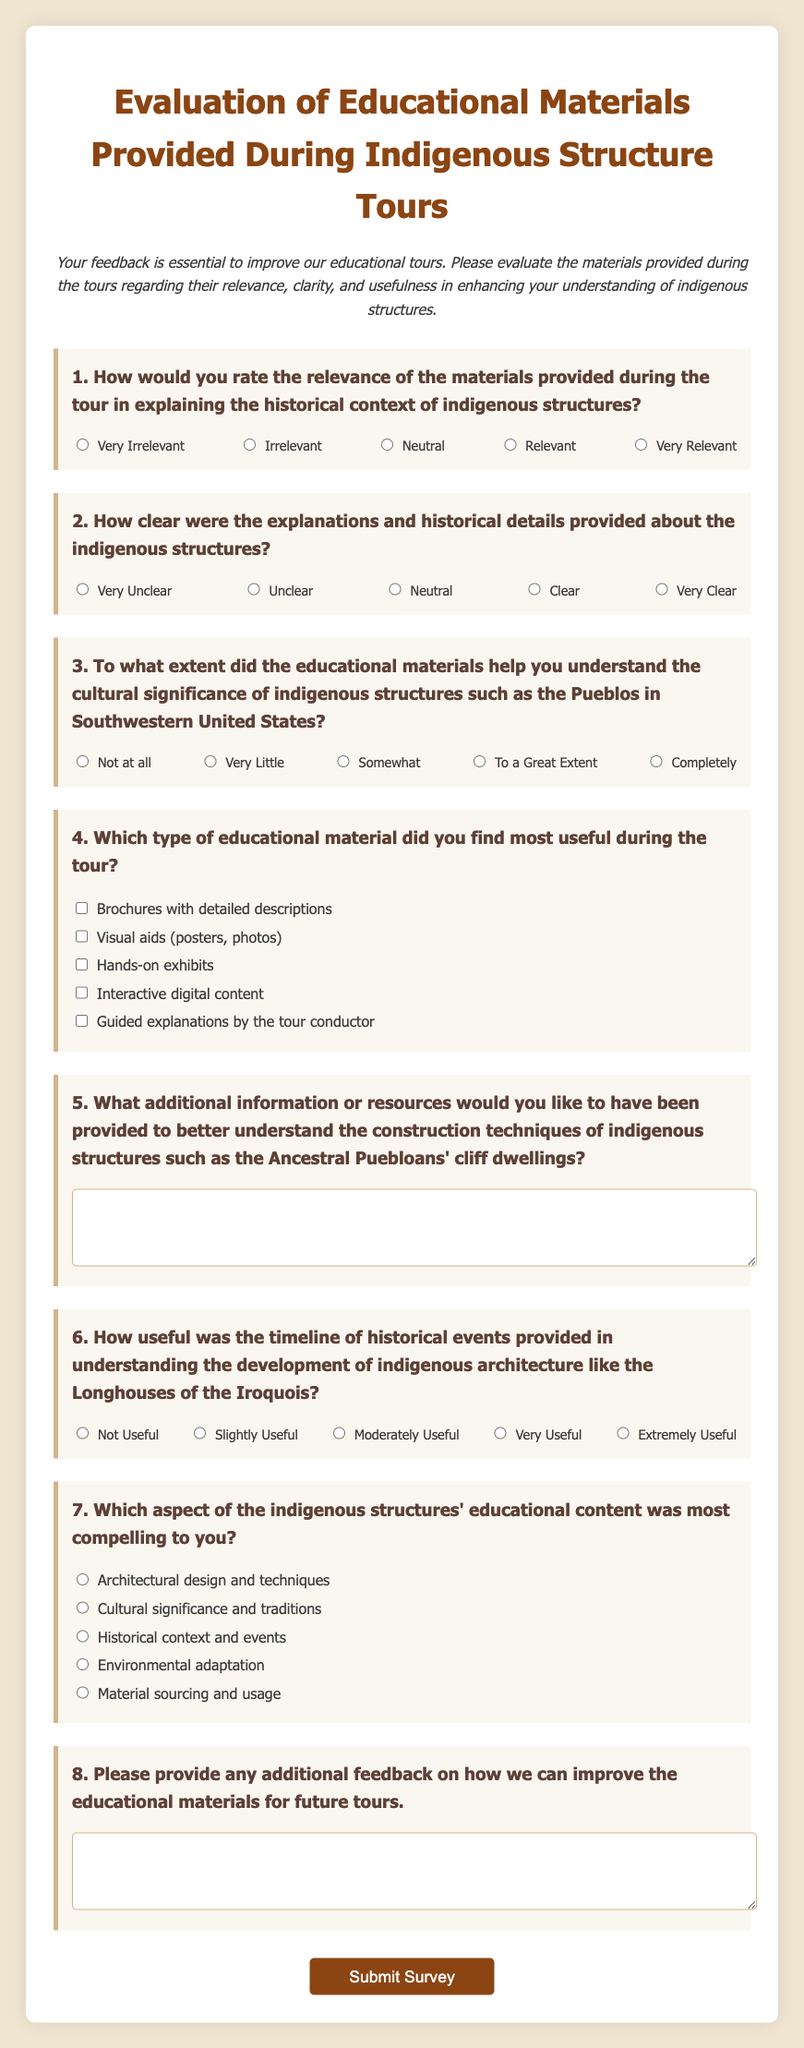What is the title of the survey? The title of the survey is mentioned at the top of the document as "Evaluation of Educational Materials Provided During Indigenous Structure Tours."
Answer: Evaluation of Educational Materials Provided During Indigenous Structure Tours What is the color of the background in the body of the document? The background color in the body of the document is specified in the CSS as "#f0e6d2."
Answer: #f0e6d2 How many main questions are included in the survey? The survey lists a total of eight main questions to be answered by the participants.
Answer: 8 What is the minimum rating on the Likert scale for question 1? The minimum rating on the Likert scale for question 1 is clearly defined as "Very Irrelevant."
Answer: Very Irrelevant Which type of educational material is listed last in question 4? The last type of educational material listed in question 4 is "Guided explanations by the tour conductor."
Answer: Guided explanations by the tour conductor Which aspect of the indigenous structures is question 7 asking about? Question 7 is specifically asking about the "aspect of the indigenous structures' educational content."
Answer: aspect of the indigenous structures' educational content What type of response does question 5 require? Question 5 requires an open-ended response, allowing participants to write their thoughts in a textarea.
Answer: open-ended response What color does the submit button change to when hovered over? The submit button changes color to "#a0522d" when hovered over according to the CSS.
Answer: #a0522d 